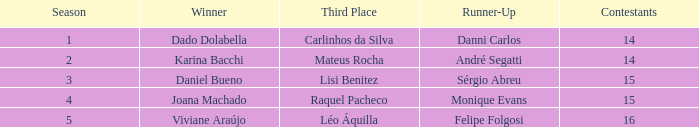In what season did Raquel Pacheco finish in third place? 4.0. 